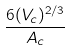<formula> <loc_0><loc_0><loc_500><loc_500>\frac { 6 ( V _ { c } ) ^ { 2 / 3 } } { A _ { c } }</formula> 